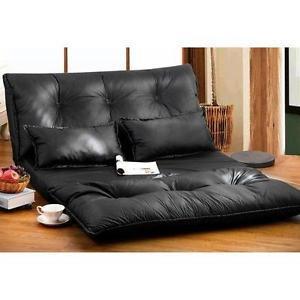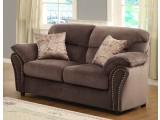The first image is the image on the left, the second image is the image on the right. Examine the images to the left and right. Is the description "A solid color loveseat on short legs with two throw pillows is in one image, with the other image showing a wide black tufted floor lounger with two matching pillows." accurate? Answer yes or no. Yes. The first image is the image on the left, the second image is the image on the right. Examine the images to the left and right. Is the description "A tufted black cushion sits like a chair without legs and has two black throw pillows on it." accurate? Answer yes or no. Yes. 